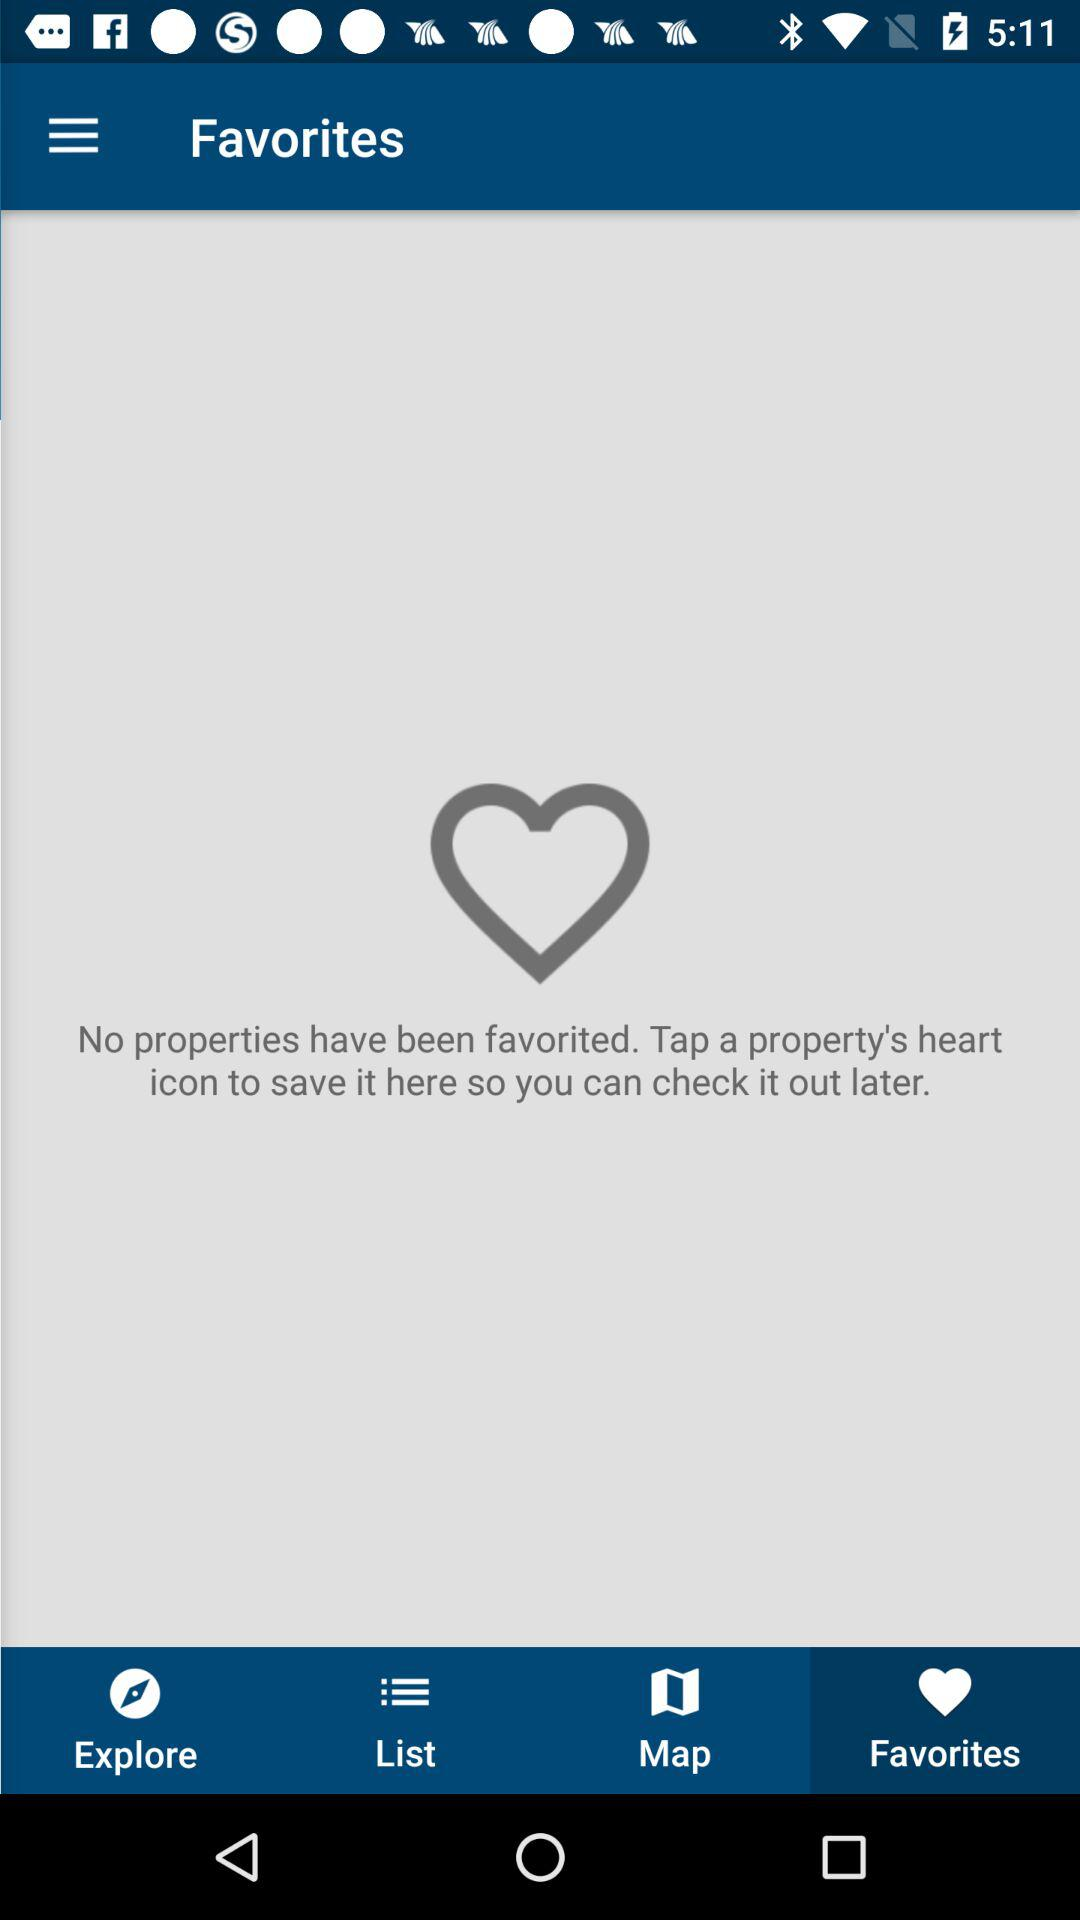How many properties have been favorited?
Answer the question using a single word or phrase. 0 